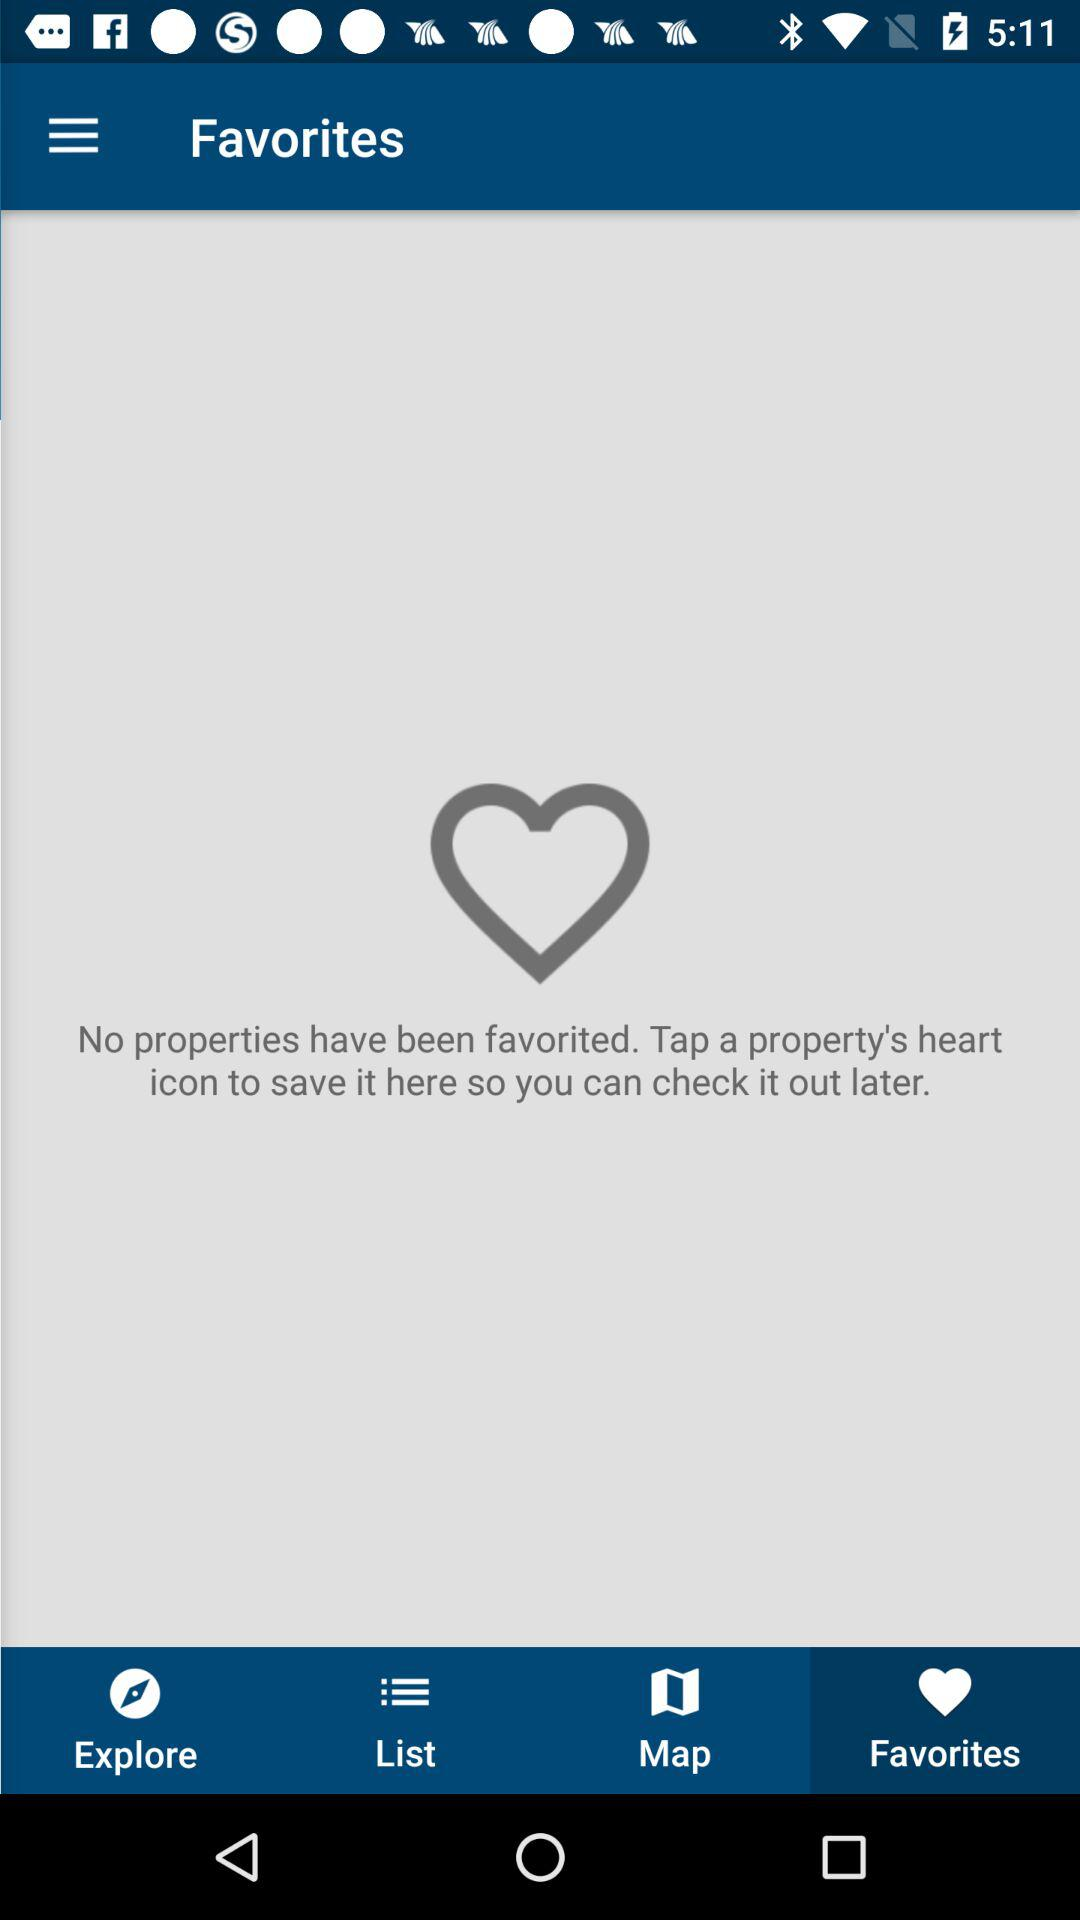How many properties have been favorited?
Answer the question using a single word or phrase. 0 